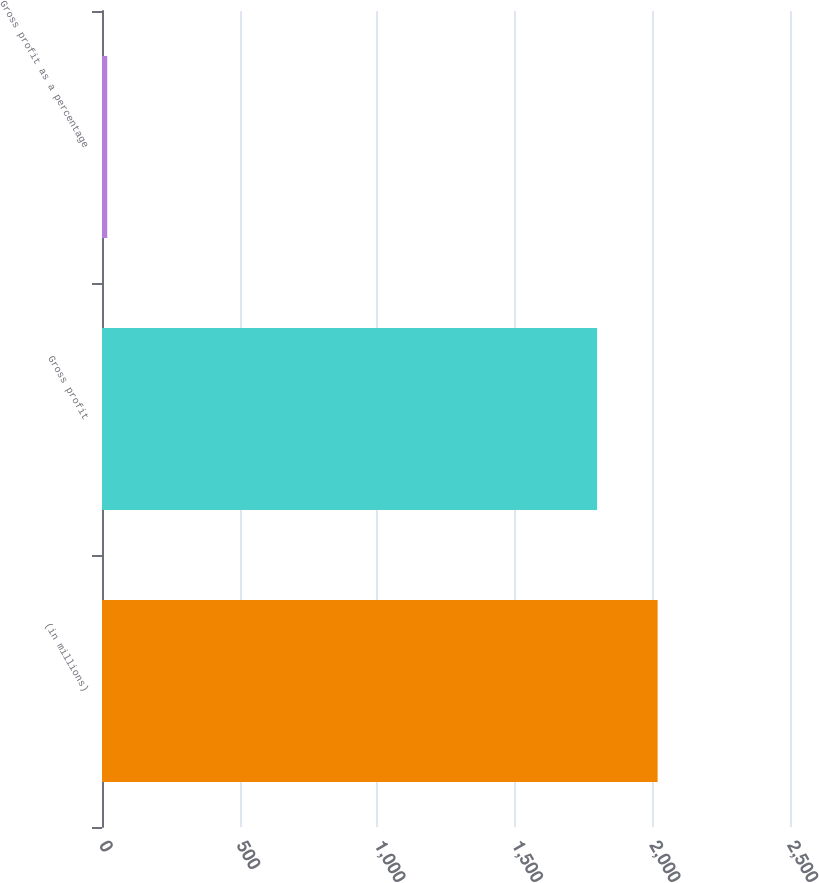Convert chart. <chart><loc_0><loc_0><loc_500><loc_500><bar_chart><fcel>(in millions)<fcel>Gross profit<fcel>Gross profit as a percentage<nl><fcel>2019<fcel>1799.1<fcel>19<nl></chart> 